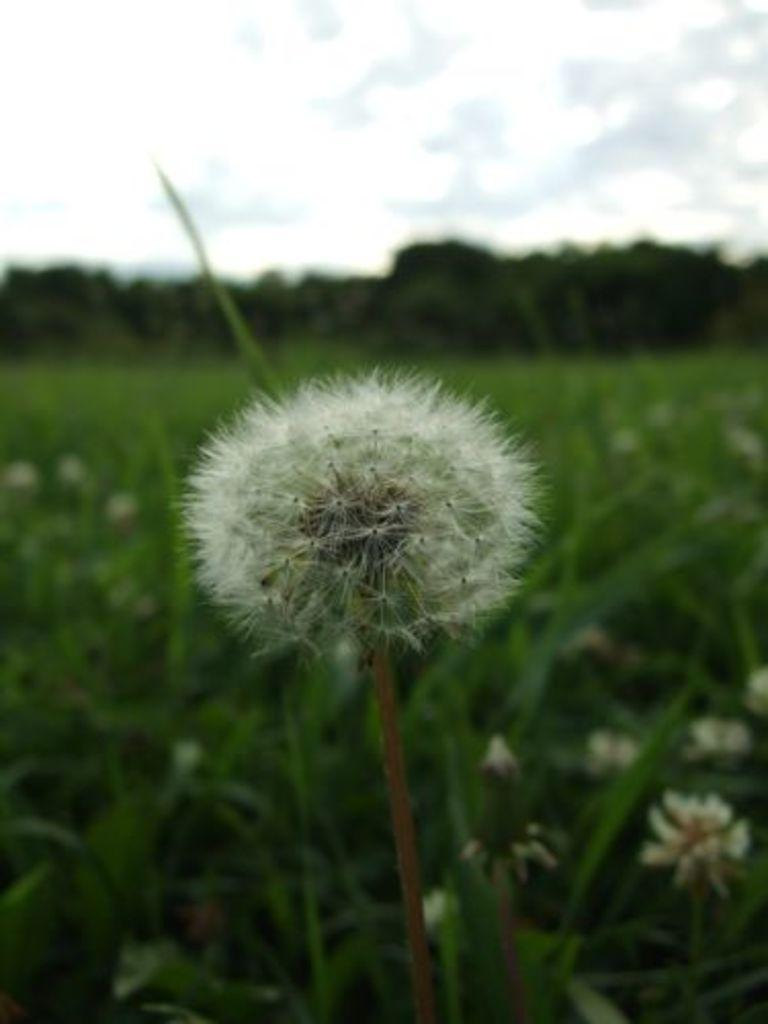What type of vegetation is on the ground in the image? There are plants and grass on the ground in the image. What specific plant can be seen in the foreground of the image? There is a dandelion in the foreground of the image. What can be seen in the background of the image? There are trees in the background of the image. What is visible at the top of the image? The sky is visible at the top of the image. Can you see the approval rating of the politician in the image? There is no mention of a politician or an approval rating in the image. Is there a receipt for the purchase of the plants in the image? There is no receipt or indication of a purchase in the image. 